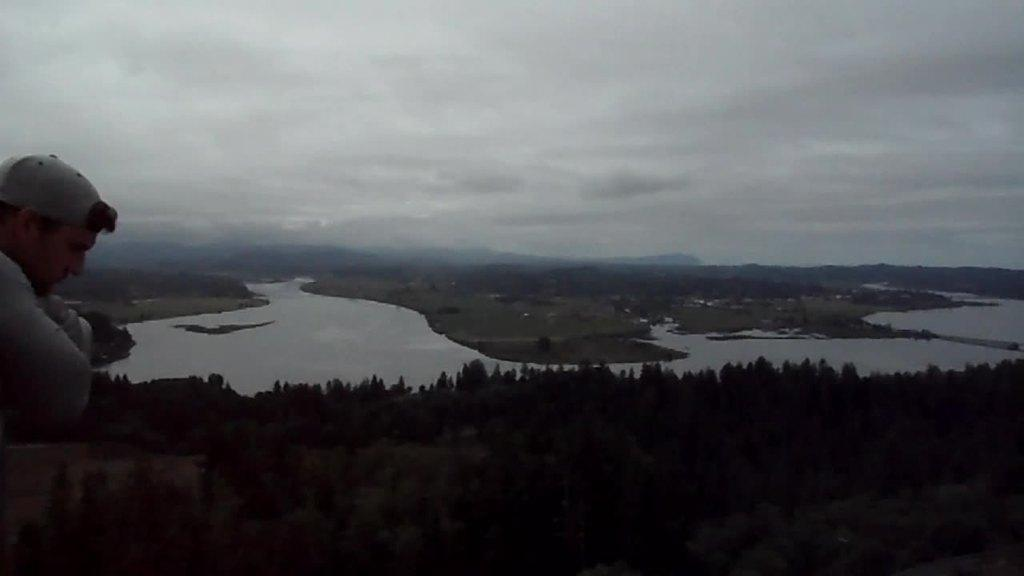Who or what is present in the image? There is a person in the image. What type of natural environment is depicted in the image? The image features trees, water, and hills. What can be seen in the background of the image? The sky is visible in the background of the image. What type of butter is being used by the person in the image? There is no butter present in the image, and the person's actions are not described. 